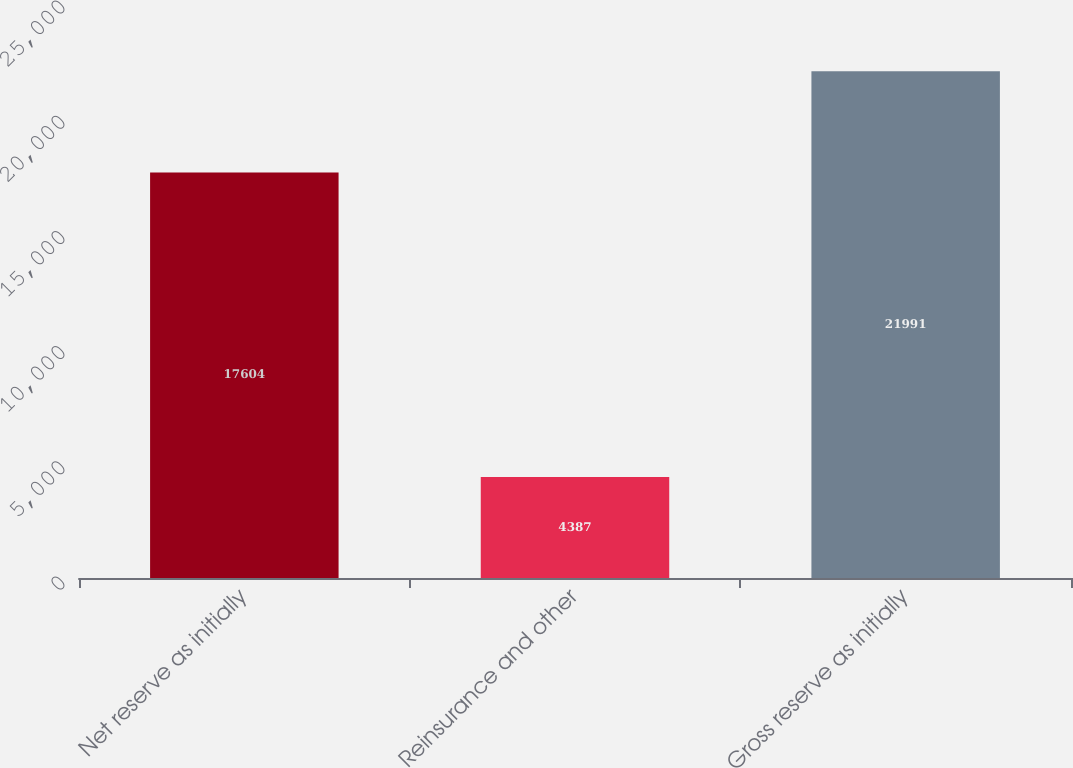<chart> <loc_0><loc_0><loc_500><loc_500><bar_chart><fcel>Net reserve as initially<fcel>Reinsurance and other<fcel>Gross reserve as initially<nl><fcel>17604<fcel>4387<fcel>21991<nl></chart> 